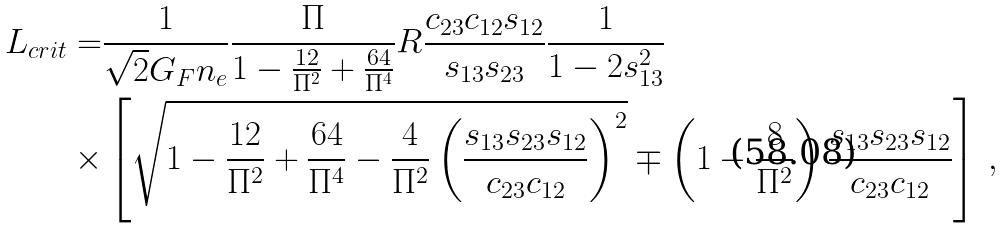<formula> <loc_0><loc_0><loc_500><loc_500>L _ { c r i t } = & \frac { 1 } { \sqrt { 2 } G _ { F } n _ { e } } \frac { \Pi } { 1 - \frac { 1 2 } { \Pi ^ { 2 } } + \frac { 6 4 } { \Pi ^ { 4 } } } R \frac { c _ { 2 3 } c _ { 1 2 } s _ { 1 2 } } { s _ { 1 3 } s _ { 2 3 } } \frac { 1 } { 1 - 2 s _ { 1 3 } ^ { 2 } } \\ \times & \left [ \sqrt { 1 - \frac { 1 2 } { \Pi ^ { 2 } } + \frac { 6 4 } { \Pi ^ { 4 } } - \frac { 4 } { \Pi ^ { 2 } } \left ( \frac { s _ { 1 3 } s _ { 2 3 } s _ { 1 2 } } { c _ { 2 3 } c _ { 1 2 } } \right ) ^ { 2 } } \mp \left ( 1 - \frac { 8 } { \Pi ^ { 2 } } \right ) \frac { s _ { 1 3 } s _ { 2 3 } s _ { 1 2 } } { c _ { 2 3 } c _ { 1 2 } } \right ] \, ,</formula> 